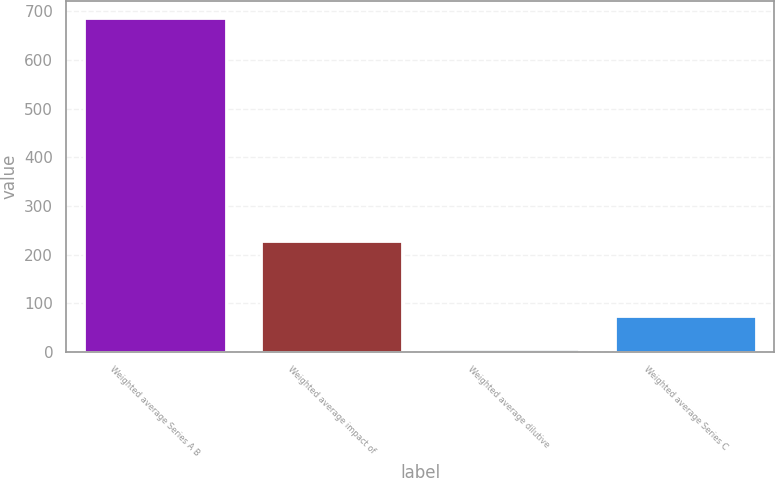<chart> <loc_0><loc_0><loc_500><loc_500><bar_chart><fcel>Weighted average Series A B<fcel>Weighted average impact of<fcel>Weighted average dilutive<fcel>Weighted average Series C<nl><fcel>687<fcel>227<fcel>6<fcel>74.1<nl></chart> 